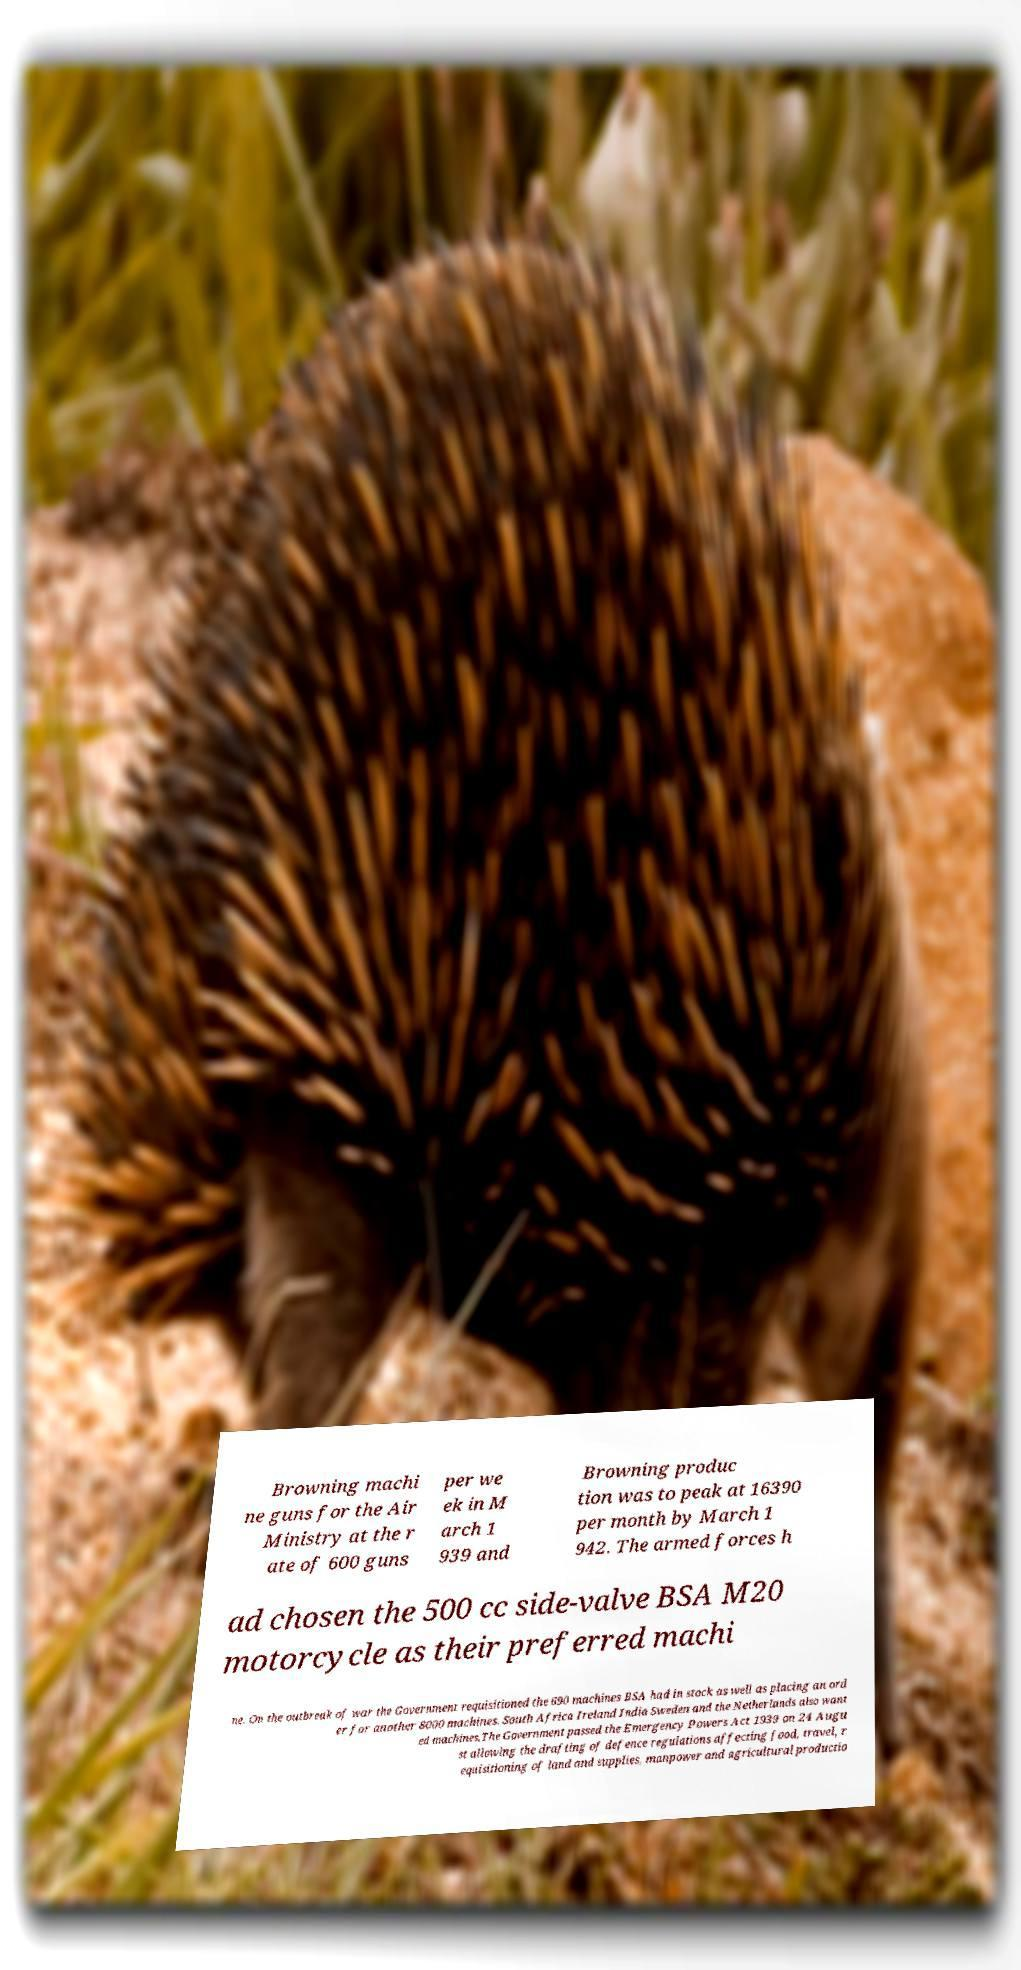Please read and relay the text visible in this image. What does it say? Browning machi ne guns for the Air Ministry at the r ate of 600 guns per we ek in M arch 1 939 and Browning produc tion was to peak at 16390 per month by March 1 942. The armed forces h ad chosen the 500 cc side-valve BSA M20 motorcycle as their preferred machi ne. On the outbreak of war the Government requisitioned the 690 machines BSA had in stock as well as placing an ord er for another 8000 machines. South Africa Ireland India Sweden and the Netherlands also want ed machines.The Government passed the Emergency Powers Act 1939 on 24 Augu st allowing the drafting of defence regulations affecting food, travel, r equisitioning of land and supplies, manpower and agricultural productio 